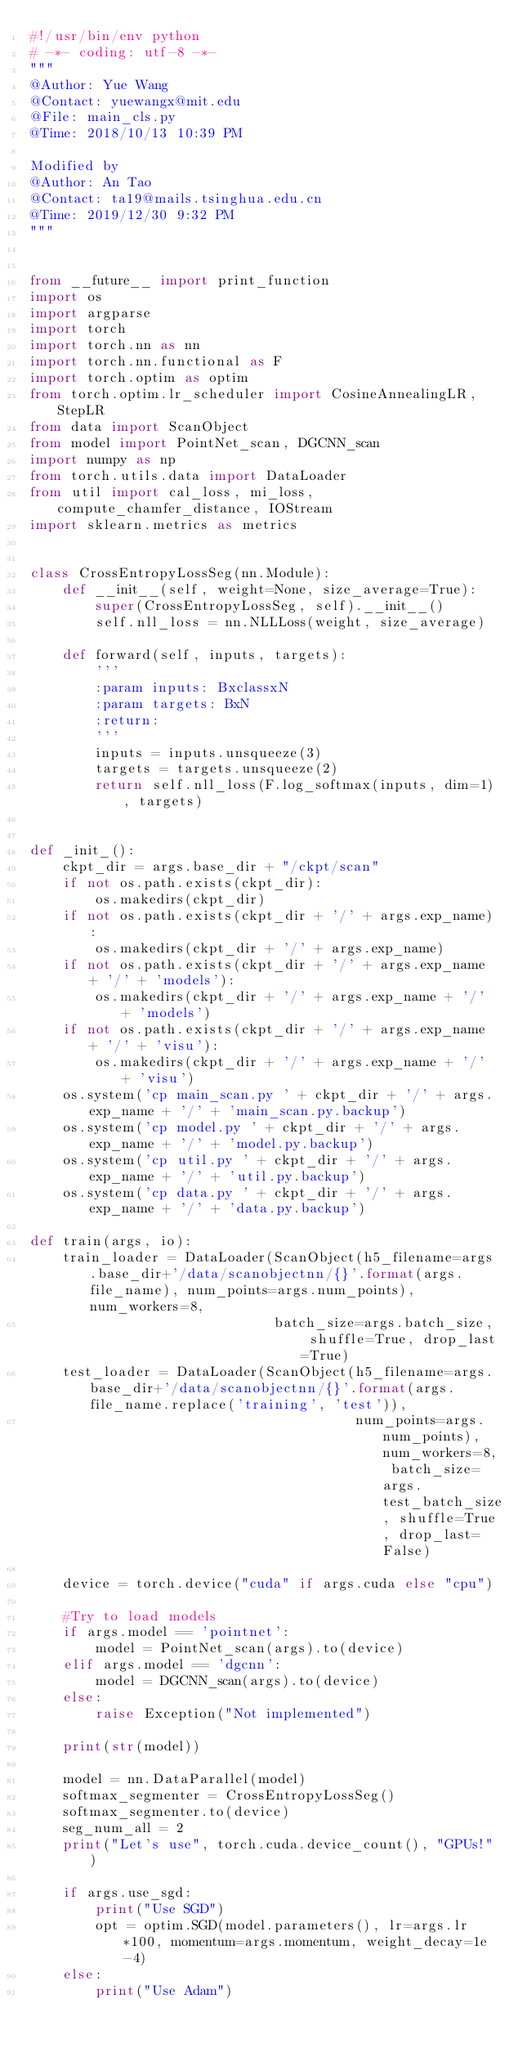<code> <loc_0><loc_0><loc_500><loc_500><_Python_>#!/usr/bin/env python
# -*- coding: utf-8 -*-
"""
@Author: Yue Wang
@Contact: yuewangx@mit.edu
@File: main_cls.py
@Time: 2018/10/13 10:39 PM

Modified by 
@Author: An Tao
@Contact: ta19@mails.tsinghua.edu.cn
@Time: 2019/12/30 9:32 PM
"""


from __future__ import print_function
import os
import argparse
import torch
import torch.nn as nn
import torch.nn.functional as F
import torch.optim as optim
from torch.optim.lr_scheduler import CosineAnnealingLR, StepLR
from data import ScanObject
from model import PointNet_scan, DGCNN_scan
import numpy as np
from torch.utils.data import DataLoader
from util import cal_loss, mi_loss, compute_chamfer_distance, IOStream
import sklearn.metrics as metrics


class CrossEntropyLossSeg(nn.Module):
    def __init__(self, weight=None, size_average=True):
        super(CrossEntropyLossSeg, self).__init__()
        self.nll_loss = nn.NLLLoss(weight, size_average)

    def forward(self, inputs, targets):
        '''
        :param inputs: BxclassxN
        :param targets: BxN
        :return:
        '''
        inputs = inputs.unsqueeze(3)
        targets = targets.unsqueeze(2)
        return self.nll_loss(F.log_softmax(inputs, dim=1), targets)


def _init_():
    ckpt_dir = args.base_dir + "/ckpt/scan"
    if not os.path.exists(ckpt_dir):
        os.makedirs(ckpt_dir)
    if not os.path.exists(ckpt_dir + '/' + args.exp_name):
        os.makedirs(ckpt_dir + '/' + args.exp_name)
    if not os.path.exists(ckpt_dir + '/' + args.exp_name + '/' + 'models'):
        os.makedirs(ckpt_dir + '/' + args.exp_name + '/' + 'models')
    if not os.path.exists(ckpt_dir + '/' + args.exp_name + '/' + 'visu'):
        os.makedirs(ckpt_dir + '/' + args.exp_name + '/' + 'visu')
    os.system('cp main_scan.py ' + ckpt_dir + '/' + args.exp_name + '/' + 'main_scan.py.backup')
    os.system('cp model.py ' + ckpt_dir + '/' + args.exp_name + '/' + 'model.py.backup')
    os.system('cp util.py ' + ckpt_dir + '/' + args.exp_name + '/' + 'util.py.backup')
    os.system('cp data.py ' + ckpt_dir + '/' + args.exp_name + '/' + 'data.py.backup')

def train(args, io):
    train_loader = DataLoader(ScanObject(h5_filename=args.base_dir+'/data/scanobjectnn/{}'.format(args.file_name), num_points=args.num_points), num_workers=8,
                              batch_size=args.batch_size, shuffle=True, drop_last=True)
    test_loader = DataLoader(ScanObject(h5_filename=args.base_dir+'/data/scanobjectnn/{}'.format(args.file_name.replace('training', 'test')),
                                        num_points=args.num_points), num_workers=8, batch_size=args.test_batch_size, shuffle=True, drop_last=False)

    device = torch.device("cuda" if args.cuda else "cpu")

    #Try to load models
    if args.model == 'pointnet':
        model = PointNet_scan(args).to(device)
    elif args.model == 'dgcnn':
        model = DGCNN_scan(args).to(device)
    else:
        raise Exception("Not implemented")

    print(str(model))

    model = nn.DataParallel(model)
    softmax_segmenter = CrossEntropyLossSeg()
    softmax_segmenter.to(device)
    seg_num_all = 2
    print("Let's use", torch.cuda.device_count(), "GPUs!")

    if args.use_sgd:
        print("Use SGD")
        opt = optim.SGD(model.parameters(), lr=args.lr*100, momentum=args.momentum, weight_decay=1e-4)
    else:
        print("Use Adam")</code> 